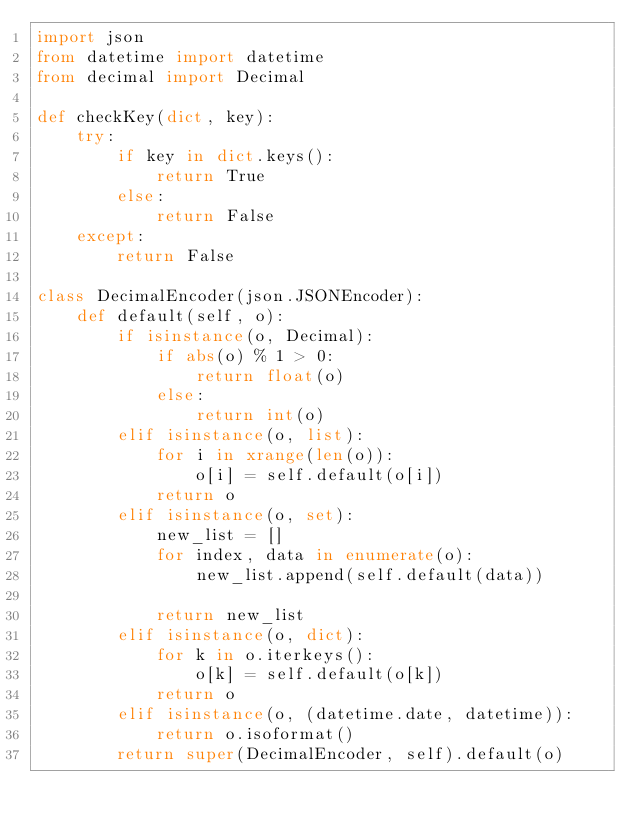Convert code to text. <code><loc_0><loc_0><loc_500><loc_500><_Python_>import json
from datetime import datetime
from decimal import Decimal

def checkKey(dict, key):
    try:
        if key in dict.keys():
            return True
        else:
            return False
    except:
        return False

class DecimalEncoder(json.JSONEncoder):
    def default(self, o):
        if isinstance(o, Decimal):
            if abs(o) % 1 > 0:
                return float(o)
            else:
                return int(o)
        elif isinstance(o, list):
            for i in xrange(len(o)):
                o[i] = self.default(o[i])
            return o
        elif isinstance(o, set):
            new_list = []
            for index, data in enumerate(o):
                new_list.append(self.default(data))
                
            return new_list
        elif isinstance(o, dict):
            for k in o.iterkeys():
                o[k] = self.default(o[k])
            return o
        elif isinstance(o, (datetime.date, datetime)):
            return o.isoformat()
        return super(DecimalEncoder, self).default(o)        </code> 